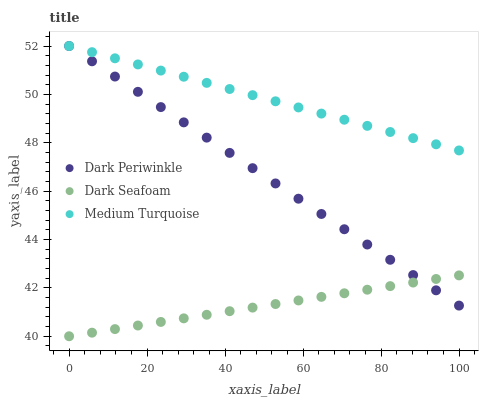Does Dark Seafoam have the minimum area under the curve?
Answer yes or no. Yes. Does Medium Turquoise have the maximum area under the curve?
Answer yes or no. Yes. Does Dark Periwinkle have the minimum area under the curve?
Answer yes or no. No. Does Dark Periwinkle have the maximum area under the curve?
Answer yes or no. No. Is Dark Seafoam the smoothest?
Answer yes or no. Yes. Is Dark Periwinkle the roughest?
Answer yes or no. Yes. Is Medium Turquoise the smoothest?
Answer yes or no. No. Is Medium Turquoise the roughest?
Answer yes or no. No. Does Dark Seafoam have the lowest value?
Answer yes or no. Yes. Does Dark Periwinkle have the lowest value?
Answer yes or no. No. Does Medium Turquoise have the highest value?
Answer yes or no. Yes. Is Dark Seafoam less than Medium Turquoise?
Answer yes or no. Yes. Is Medium Turquoise greater than Dark Seafoam?
Answer yes or no. Yes. Does Dark Periwinkle intersect Medium Turquoise?
Answer yes or no. Yes. Is Dark Periwinkle less than Medium Turquoise?
Answer yes or no. No. Is Dark Periwinkle greater than Medium Turquoise?
Answer yes or no. No. Does Dark Seafoam intersect Medium Turquoise?
Answer yes or no. No. 